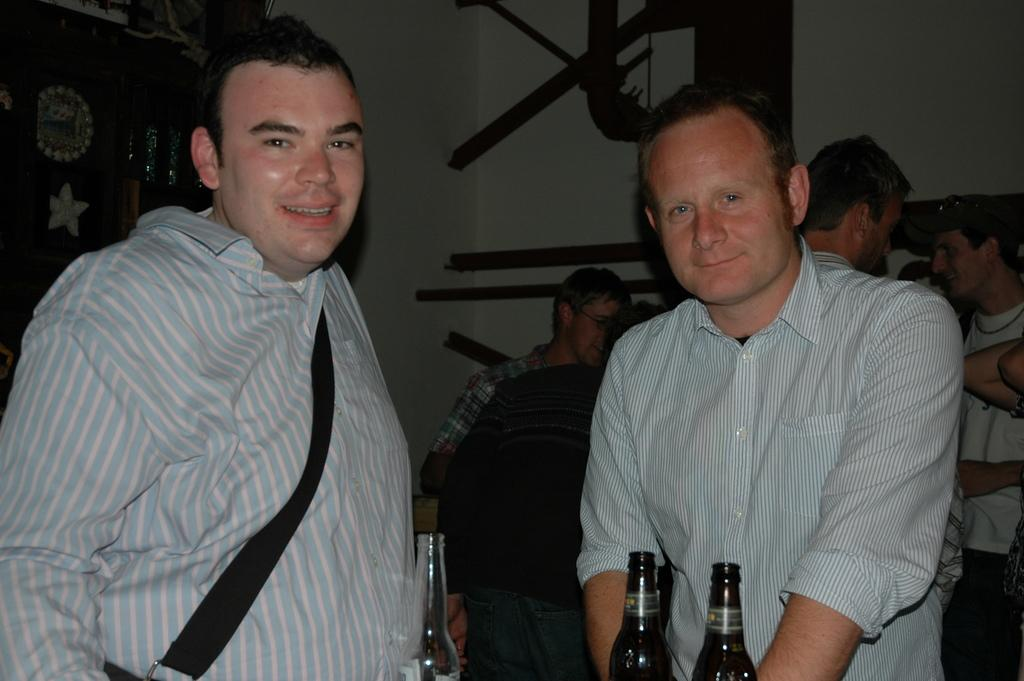How many people are in the image? There is a group of people in the image, but the exact number is not specified. What are some of the people in the image doing? Some people are standing, and some people are sitting on chairs. What is on the table in the image? There are bottles on the table. What might the people be using the chairs for? The chairs might be used for sitting and resting during a gathering or event. What time of day is depicted in the image? The provided facts do not mention the time of day, so it cannot be determined from the image. Can you see a toothbrush or pin in the image? No, there is no toothbrush or pin present in the image. 